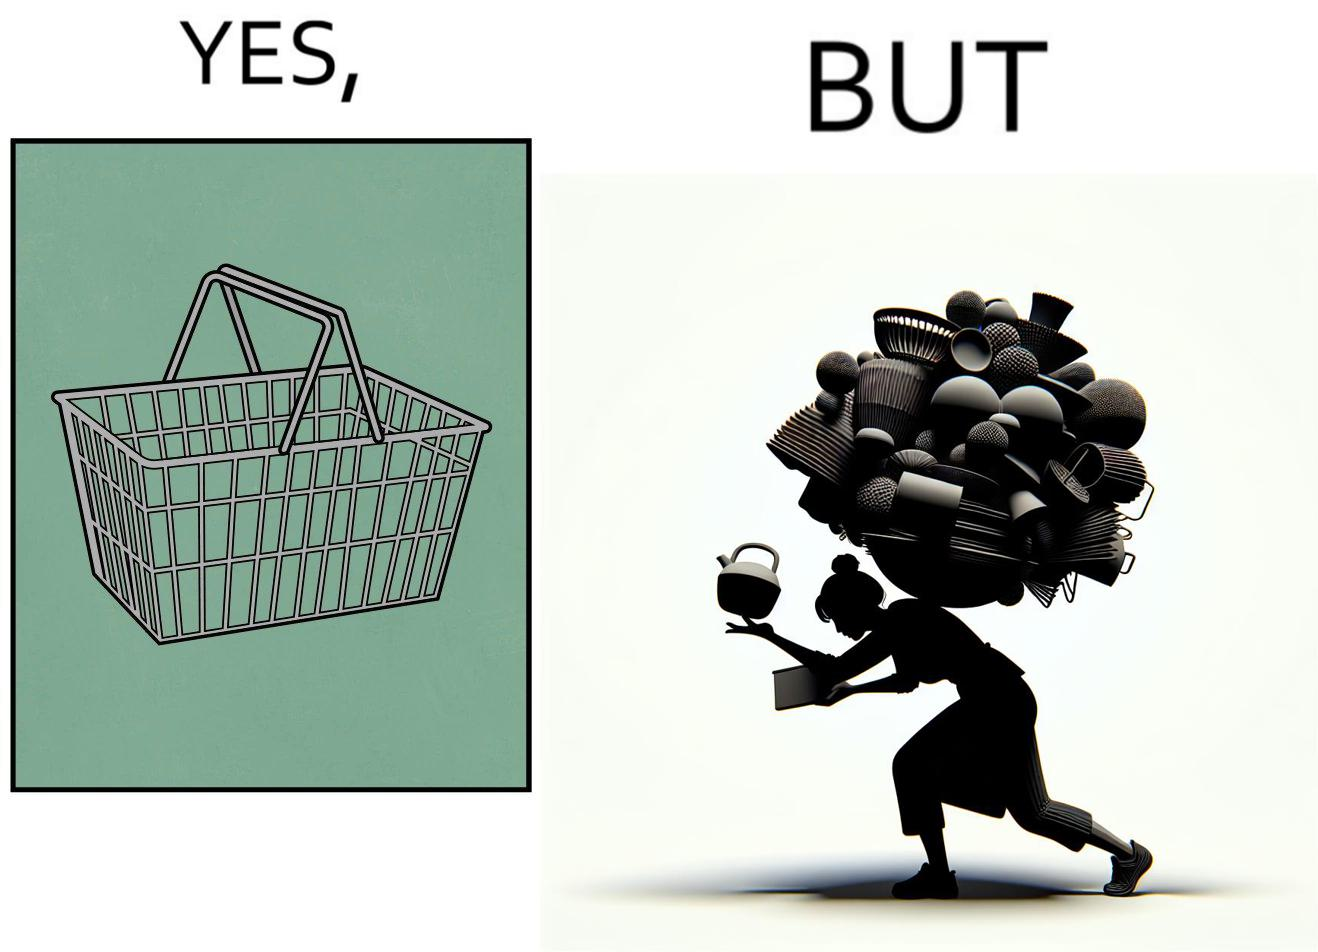Is this a satirical image? Yes, this image is satirical. 